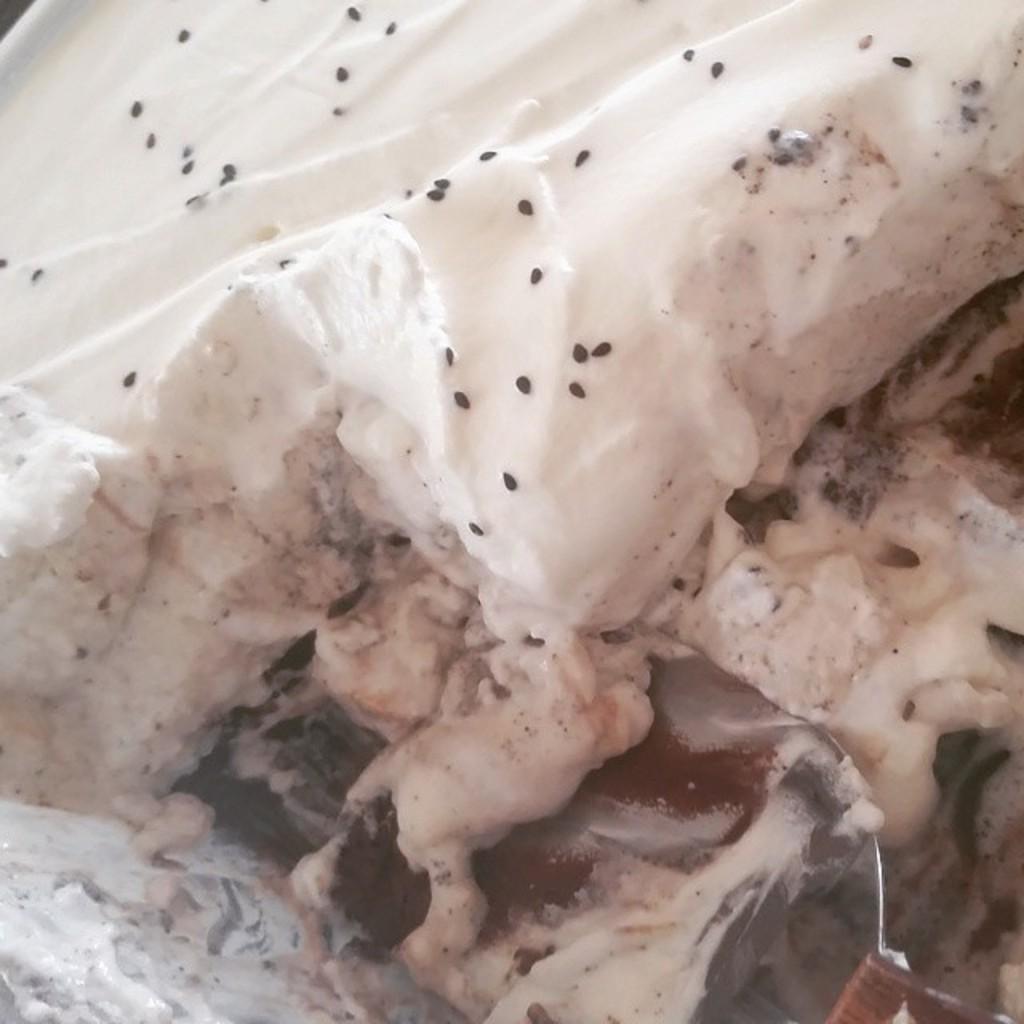Describe this image in one or two sentences. There is a food item with white cream, chocolate and sesame seeds. Also there is spoon. 